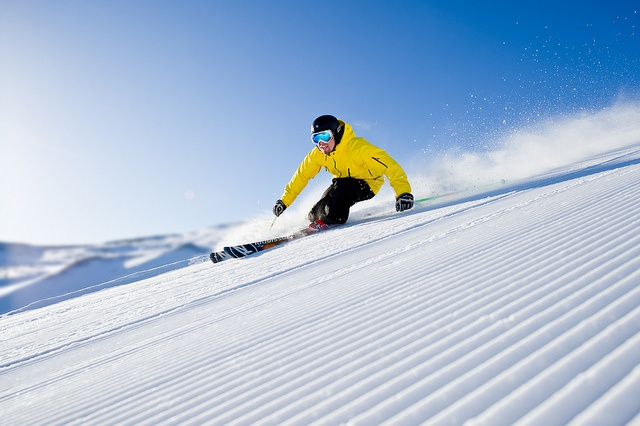Describe the objects in this image and their specific colors. I can see people in darkgray, black, gold, and lightgray tones and skis in darkgray, black, gray, and navy tones in this image. 